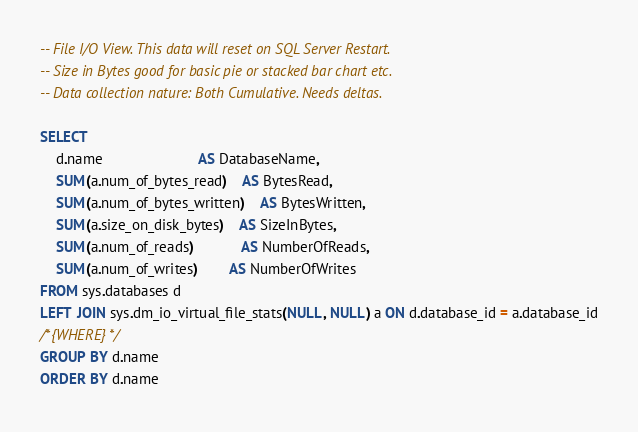Convert code to text. <code><loc_0><loc_0><loc_500><loc_500><_SQL_>-- File I/O View. This data will reset on SQL Server Restart.
-- Size in Bytes good for basic pie or stacked bar chart etc.
-- Data collection nature: Both Cumulative. Needs deltas.

SELECT
	d.name						AS DatabaseName,
	SUM(a.num_of_bytes_read)	AS BytesRead,
	SUM(a.num_of_bytes_written)	AS BytesWritten,
	SUM(a.size_on_disk_bytes)	AS SizeInBytes,
	SUM(a.num_of_reads)			AS NumberOfReads,
	SUM(a.num_of_writes)		AS NumberOfWrites
FROM sys.databases d
LEFT JOIN sys.dm_io_virtual_file_stats(NULL, NULL) a ON d.database_id = a.database_id
/*{WHERE}*/
GROUP BY d.name
ORDER BY d.name</code> 